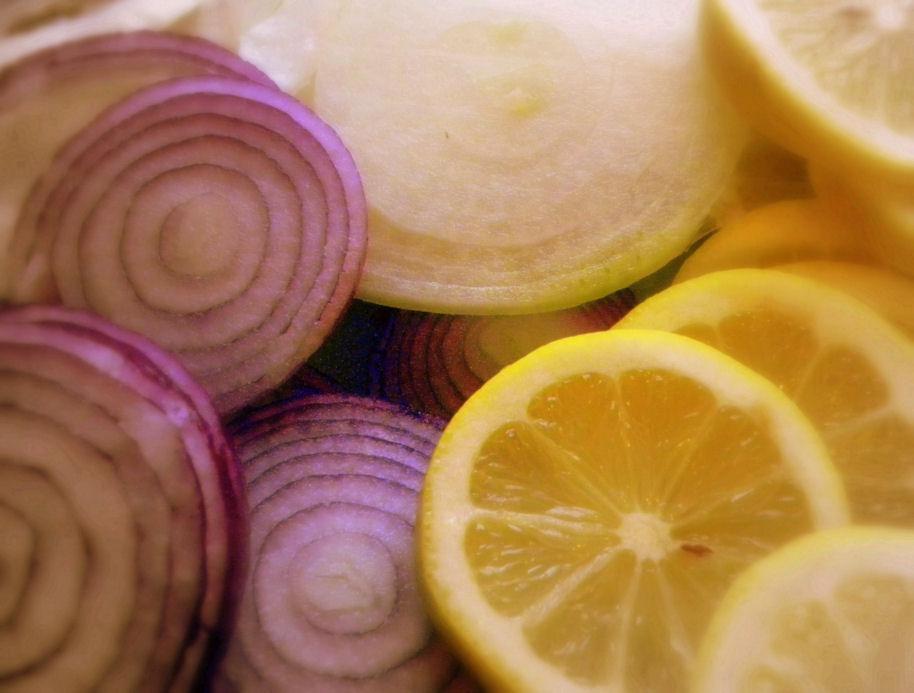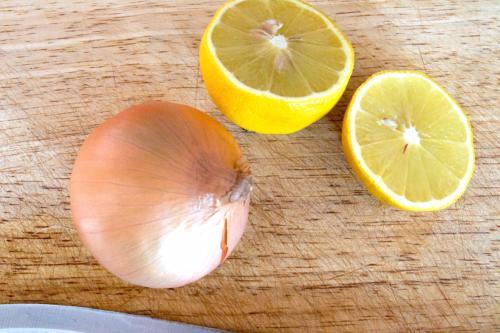The first image is the image on the left, the second image is the image on the right. Examine the images to the left and right. Is the description "An image includes a whole onion and a half lemon, but not a whole lemon or a half onion." accurate? Answer yes or no. Yes. The first image is the image on the left, the second image is the image on the right. Given the left and right images, does the statement "In one of the images there is a whole lemon next to a whole onion." hold true? Answer yes or no. No. 